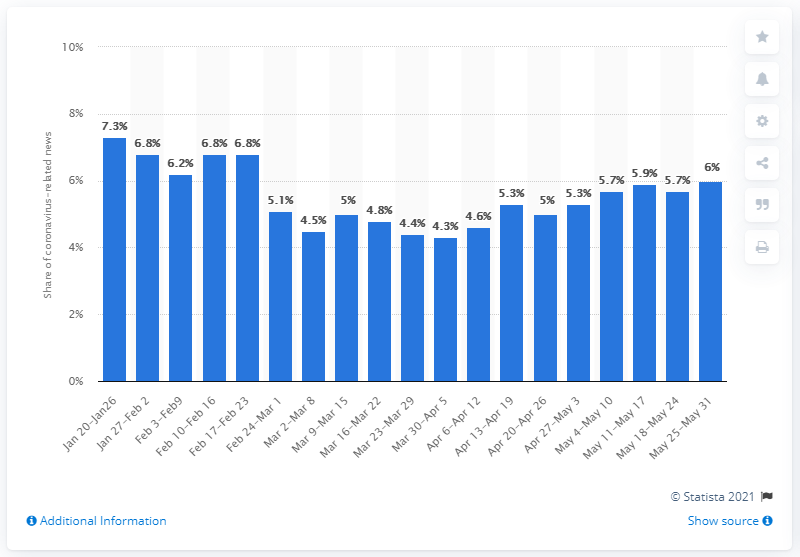Mention a couple of crucial points in this snapshot. Approximately 7.3% of the information related to the coronavirus at the end of January 2020 was false or not accurate. 